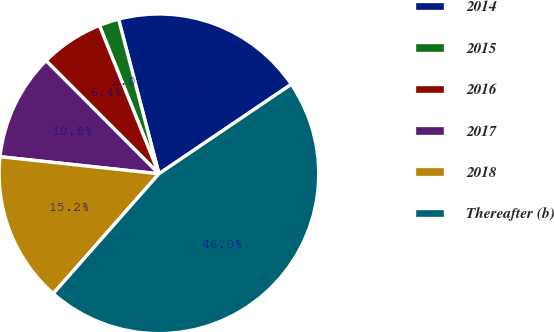<chart> <loc_0><loc_0><loc_500><loc_500><pie_chart><fcel>2014<fcel>2015<fcel>2016<fcel>2017<fcel>2018<fcel>Thereafter (b)<nl><fcel>19.6%<fcel>2.01%<fcel>6.41%<fcel>10.81%<fcel>15.2%<fcel>45.97%<nl></chart> 